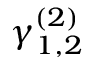Convert formula to latex. <formula><loc_0><loc_0><loc_500><loc_500>\gamma _ { 1 , 2 } ^ { ( 2 ) }</formula> 